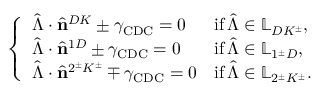<formula> <loc_0><loc_0><loc_500><loc_500>\left \{ \begin{array} { l l } { \hat { \Lambda } \cdot \hat { n } ^ { D K } \pm \gamma _ { C D C } = 0 } & { i f \, \hat { \Lambda } \in \mathbb { L } _ { D K ^ { \pm } } , } \\ { \hat { \Lambda } \cdot \hat { n } ^ { 1 D } \pm \gamma _ { C D C } = 0 } & { i f \, \hat { \Lambda } \in \mathbb { L } _ { 1 ^ { \pm } D } , } \\ { \hat { \Lambda } \cdot \hat { n } ^ { 2 ^ { \pm } K ^ { \pm } } \mp \gamma _ { C D C } = 0 } & { i f \, \hat { \Lambda } \in \mathbb { L } _ { 2 ^ { \pm } K ^ { \pm } } . } \end{array}</formula> 